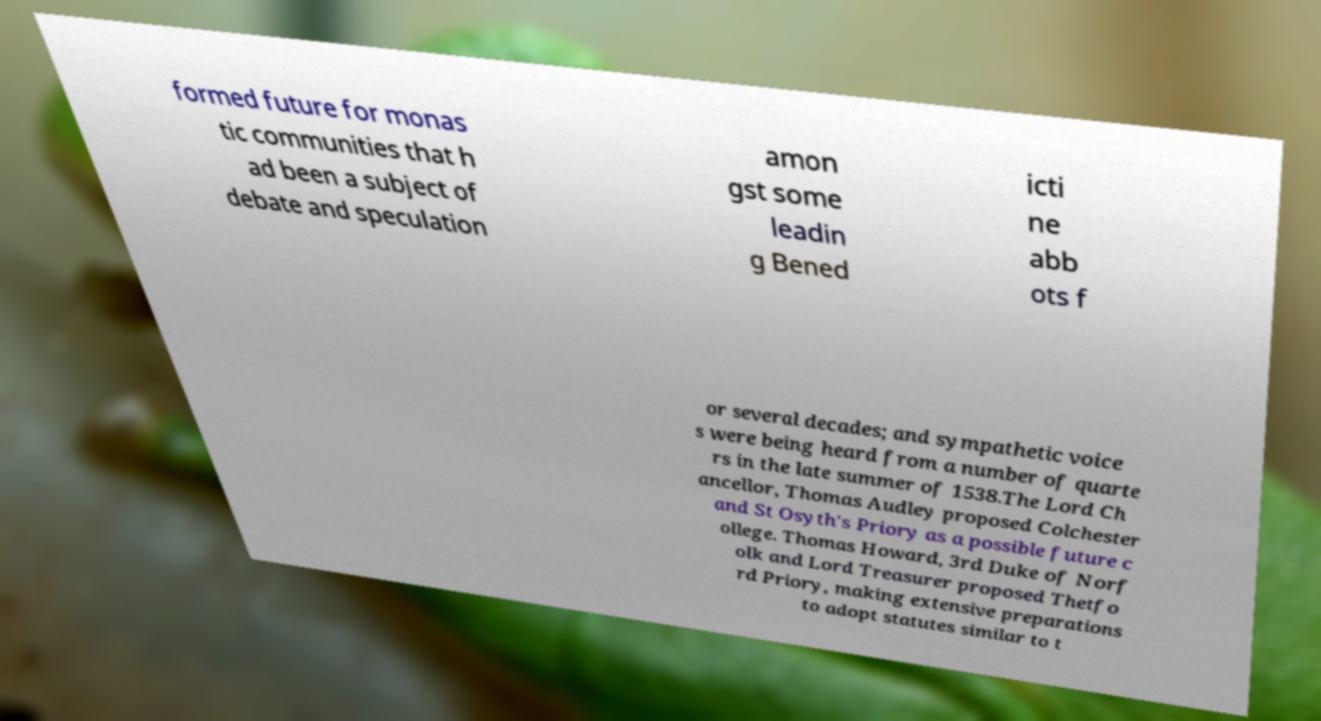Can you accurately transcribe the text from the provided image for me? formed future for monas tic communities that h ad been a subject of debate and speculation amon gst some leadin g Bened icti ne abb ots f or several decades; and sympathetic voice s were being heard from a number of quarte rs in the late summer of 1538.The Lord Ch ancellor, Thomas Audley proposed Colchester and St Osyth's Priory as a possible future c ollege. Thomas Howard, 3rd Duke of Norf olk and Lord Treasurer proposed Thetfo rd Priory, making extensive preparations to adopt statutes similar to t 